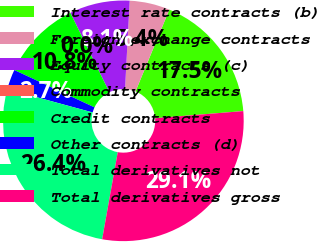Convert chart. <chart><loc_0><loc_0><loc_500><loc_500><pie_chart><fcel>Interest rate contracts (b)<fcel>Foreign exchange contracts<fcel>Equity contracts (c)<fcel>Commodity contracts<fcel>Credit contracts<fcel>Other contracts (d)<fcel>Total derivatives not<fcel>Total derivatives gross<nl><fcel>17.47%<fcel>5.4%<fcel>8.1%<fcel>0.0%<fcel>10.8%<fcel>2.7%<fcel>26.41%<fcel>29.11%<nl></chart> 